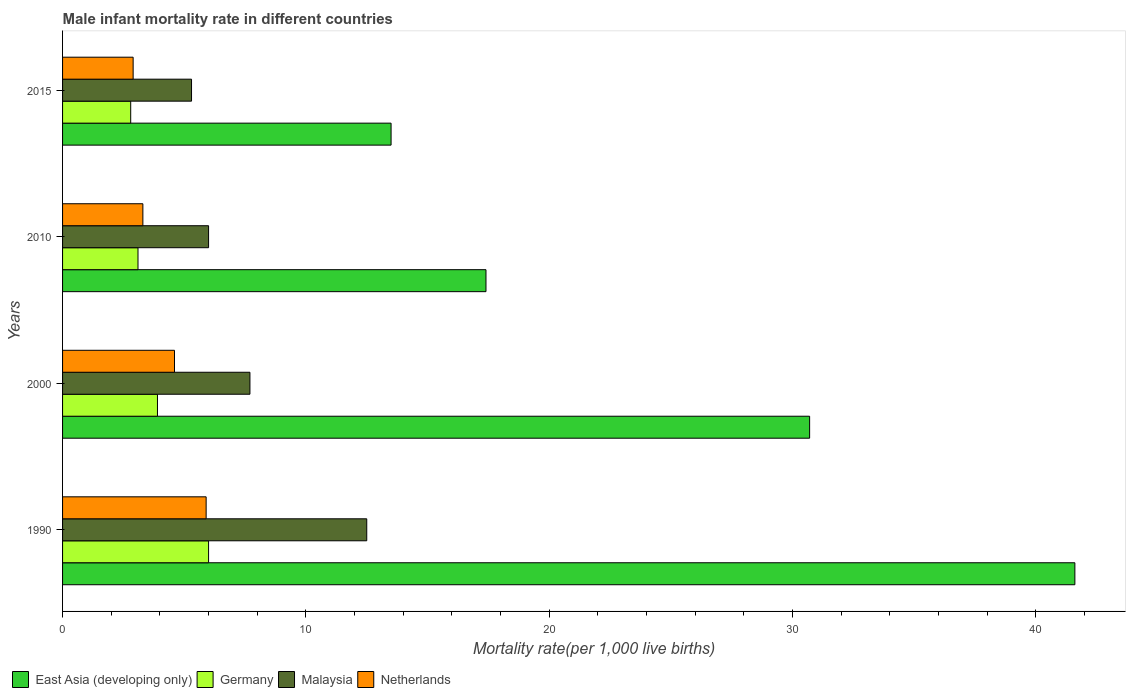How many groups of bars are there?
Make the answer very short. 4. Are the number of bars on each tick of the Y-axis equal?
Make the answer very short. Yes. How many bars are there on the 1st tick from the top?
Your answer should be compact. 4. In how many cases, is the number of bars for a given year not equal to the number of legend labels?
Offer a terse response. 0. What is the male infant mortality rate in East Asia (developing only) in 2000?
Provide a short and direct response. 30.7. Across all years, what is the maximum male infant mortality rate in East Asia (developing only)?
Your answer should be very brief. 41.6. Across all years, what is the minimum male infant mortality rate in Netherlands?
Ensure brevity in your answer.  2.9. In which year was the male infant mortality rate in Malaysia minimum?
Your answer should be compact. 2015. What is the total male infant mortality rate in East Asia (developing only) in the graph?
Offer a terse response. 103.2. What is the difference between the male infant mortality rate in East Asia (developing only) in 2000 and the male infant mortality rate in Germany in 2015?
Your response must be concise. 27.9. What is the average male infant mortality rate in Netherlands per year?
Your response must be concise. 4.17. In the year 2000, what is the difference between the male infant mortality rate in Germany and male infant mortality rate in East Asia (developing only)?
Ensure brevity in your answer.  -26.8. What is the ratio of the male infant mortality rate in Germany in 2010 to that in 2015?
Provide a succinct answer. 1.11. Is the difference between the male infant mortality rate in Germany in 1990 and 2010 greater than the difference between the male infant mortality rate in East Asia (developing only) in 1990 and 2010?
Provide a succinct answer. No. What is the difference between the highest and the second highest male infant mortality rate in Malaysia?
Provide a short and direct response. 4.8. What is the difference between the highest and the lowest male infant mortality rate in East Asia (developing only)?
Ensure brevity in your answer.  28.1. In how many years, is the male infant mortality rate in Germany greater than the average male infant mortality rate in Germany taken over all years?
Make the answer very short. 1. Is it the case that in every year, the sum of the male infant mortality rate in Netherlands and male infant mortality rate in East Asia (developing only) is greater than the sum of male infant mortality rate in Germany and male infant mortality rate in Malaysia?
Provide a succinct answer. No. What does the 2nd bar from the bottom in 1990 represents?
Your response must be concise. Germany. Is it the case that in every year, the sum of the male infant mortality rate in Malaysia and male infant mortality rate in Germany is greater than the male infant mortality rate in East Asia (developing only)?
Make the answer very short. No. Are all the bars in the graph horizontal?
Provide a short and direct response. Yes. How many years are there in the graph?
Keep it short and to the point. 4. Does the graph contain any zero values?
Provide a short and direct response. No. How many legend labels are there?
Your answer should be compact. 4. What is the title of the graph?
Your answer should be very brief. Male infant mortality rate in different countries. Does "Italy" appear as one of the legend labels in the graph?
Provide a short and direct response. No. What is the label or title of the X-axis?
Give a very brief answer. Mortality rate(per 1,0 live births). What is the Mortality rate(per 1,000 live births) of East Asia (developing only) in 1990?
Your answer should be very brief. 41.6. What is the Mortality rate(per 1,000 live births) in Malaysia in 1990?
Give a very brief answer. 12.5. What is the Mortality rate(per 1,000 live births) in East Asia (developing only) in 2000?
Offer a very short reply. 30.7. What is the Mortality rate(per 1,000 live births) in Malaysia in 2000?
Provide a short and direct response. 7.7. What is the Mortality rate(per 1,000 live births) in Netherlands in 2000?
Your answer should be compact. 4.6. What is the Mortality rate(per 1,000 live births) in Germany in 2010?
Your answer should be very brief. 3.1. What is the Mortality rate(per 1,000 live births) of Netherlands in 2010?
Keep it short and to the point. 3.3. What is the Mortality rate(per 1,000 live births) in Germany in 2015?
Offer a terse response. 2.8. What is the Mortality rate(per 1,000 live births) in Netherlands in 2015?
Give a very brief answer. 2.9. Across all years, what is the maximum Mortality rate(per 1,000 live births) of East Asia (developing only)?
Your answer should be very brief. 41.6. Across all years, what is the maximum Mortality rate(per 1,000 live births) of Malaysia?
Make the answer very short. 12.5. Across all years, what is the minimum Mortality rate(per 1,000 live births) of Germany?
Your response must be concise. 2.8. Across all years, what is the minimum Mortality rate(per 1,000 live births) in Malaysia?
Provide a succinct answer. 5.3. What is the total Mortality rate(per 1,000 live births) of East Asia (developing only) in the graph?
Your response must be concise. 103.2. What is the total Mortality rate(per 1,000 live births) of Germany in the graph?
Provide a succinct answer. 15.8. What is the total Mortality rate(per 1,000 live births) in Malaysia in the graph?
Keep it short and to the point. 31.5. What is the difference between the Mortality rate(per 1,000 live births) in East Asia (developing only) in 1990 and that in 2000?
Your answer should be compact. 10.9. What is the difference between the Mortality rate(per 1,000 live births) in Malaysia in 1990 and that in 2000?
Offer a terse response. 4.8. What is the difference between the Mortality rate(per 1,000 live births) in Netherlands in 1990 and that in 2000?
Offer a very short reply. 1.3. What is the difference between the Mortality rate(per 1,000 live births) of East Asia (developing only) in 1990 and that in 2010?
Offer a very short reply. 24.2. What is the difference between the Mortality rate(per 1,000 live births) in Netherlands in 1990 and that in 2010?
Make the answer very short. 2.6. What is the difference between the Mortality rate(per 1,000 live births) in East Asia (developing only) in 1990 and that in 2015?
Keep it short and to the point. 28.1. What is the difference between the Mortality rate(per 1,000 live births) of Netherlands in 1990 and that in 2015?
Ensure brevity in your answer.  3. What is the difference between the Mortality rate(per 1,000 live births) of East Asia (developing only) in 2000 and that in 2015?
Provide a succinct answer. 17.2. What is the difference between the Mortality rate(per 1,000 live births) in Germany in 2000 and that in 2015?
Make the answer very short. 1.1. What is the difference between the Mortality rate(per 1,000 live births) in Netherlands in 2000 and that in 2015?
Your answer should be compact. 1.7. What is the difference between the Mortality rate(per 1,000 live births) of Netherlands in 2010 and that in 2015?
Ensure brevity in your answer.  0.4. What is the difference between the Mortality rate(per 1,000 live births) in East Asia (developing only) in 1990 and the Mortality rate(per 1,000 live births) in Germany in 2000?
Your response must be concise. 37.7. What is the difference between the Mortality rate(per 1,000 live births) of East Asia (developing only) in 1990 and the Mortality rate(per 1,000 live births) of Malaysia in 2000?
Keep it short and to the point. 33.9. What is the difference between the Mortality rate(per 1,000 live births) of East Asia (developing only) in 1990 and the Mortality rate(per 1,000 live births) of Netherlands in 2000?
Provide a short and direct response. 37. What is the difference between the Mortality rate(per 1,000 live births) of East Asia (developing only) in 1990 and the Mortality rate(per 1,000 live births) of Germany in 2010?
Keep it short and to the point. 38.5. What is the difference between the Mortality rate(per 1,000 live births) of East Asia (developing only) in 1990 and the Mortality rate(per 1,000 live births) of Malaysia in 2010?
Give a very brief answer. 35.6. What is the difference between the Mortality rate(per 1,000 live births) in East Asia (developing only) in 1990 and the Mortality rate(per 1,000 live births) in Netherlands in 2010?
Give a very brief answer. 38.3. What is the difference between the Mortality rate(per 1,000 live births) in Germany in 1990 and the Mortality rate(per 1,000 live births) in Malaysia in 2010?
Make the answer very short. 0. What is the difference between the Mortality rate(per 1,000 live births) in Malaysia in 1990 and the Mortality rate(per 1,000 live births) in Netherlands in 2010?
Your answer should be compact. 9.2. What is the difference between the Mortality rate(per 1,000 live births) in East Asia (developing only) in 1990 and the Mortality rate(per 1,000 live births) in Germany in 2015?
Provide a succinct answer. 38.8. What is the difference between the Mortality rate(per 1,000 live births) of East Asia (developing only) in 1990 and the Mortality rate(per 1,000 live births) of Malaysia in 2015?
Ensure brevity in your answer.  36.3. What is the difference between the Mortality rate(per 1,000 live births) of East Asia (developing only) in 1990 and the Mortality rate(per 1,000 live births) of Netherlands in 2015?
Provide a short and direct response. 38.7. What is the difference between the Mortality rate(per 1,000 live births) in Germany in 1990 and the Mortality rate(per 1,000 live births) in Netherlands in 2015?
Your answer should be compact. 3.1. What is the difference between the Mortality rate(per 1,000 live births) of East Asia (developing only) in 2000 and the Mortality rate(per 1,000 live births) of Germany in 2010?
Keep it short and to the point. 27.6. What is the difference between the Mortality rate(per 1,000 live births) of East Asia (developing only) in 2000 and the Mortality rate(per 1,000 live births) of Malaysia in 2010?
Give a very brief answer. 24.7. What is the difference between the Mortality rate(per 1,000 live births) of East Asia (developing only) in 2000 and the Mortality rate(per 1,000 live births) of Netherlands in 2010?
Make the answer very short. 27.4. What is the difference between the Mortality rate(per 1,000 live births) of Germany in 2000 and the Mortality rate(per 1,000 live births) of Malaysia in 2010?
Offer a terse response. -2.1. What is the difference between the Mortality rate(per 1,000 live births) of Malaysia in 2000 and the Mortality rate(per 1,000 live births) of Netherlands in 2010?
Ensure brevity in your answer.  4.4. What is the difference between the Mortality rate(per 1,000 live births) in East Asia (developing only) in 2000 and the Mortality rate(per 1,000 live births) in Germany in 2015?
Your answer should be very brief. 27.9. What is the difference between the Mortality rate(per 1,000 live births) of East Asia (developing only) in 2000 and the Mortality rate(per 1,000 live births) of Malaysia in 2015?
Offer a very short reply. 25.4. What is the difference between the Mortality rate(per 1,000 live births) of East Asia (developing only) in 2000 and the Mortality rate(per 1,000 live births) of Netherlands in 2015?
Keep it short and to the point. 27.8. What is the difference between the Mortality rate(per 1,000 live births) of Germany in 2000 and the Mortality rate(per 1,000 live births) of Malaysia in 2015?
Ensure brevity in your answer.  -1.4. What is the difference between the Mortality rate(per 1,000 live births) in Malaysia in 2000 and the Mortality rate(per 1,000 live births) in Netherlands in 2015?
Offer a very short reply. 4.8. What is the difference between the Mortality rate(per 1,000 live births) of East Asia (developing only) in 2010 and the Mortality rate(per 1,000 live births) of Germany in 2015?
Provide a short and direct response. 14.6. What is the difference between the Mortality rate(per 1,000 live births) in Germany in 2010 and the Mortality rate(per 1,000 live births) in Malaysia in 2015?
Ensure brevity in your answer.  -2.2. What is the difference between the Mortality rate(per 1,000 live births) in Malaysia in 2010 and the Mortality rate(per 1,000 live births) in Netherlands in 2015?
Your answer should be very brief. 3.1. What is the average Mortality rate(per 1,000 live births) of East Asia (developing only) per year?
Your answer should be compact. 25.8. What is the average Mortality rate(per 1,000 live births) in Germany per year?
Provide a short and direct response. 3.95. What is the average Mortality rate(per 1,000 live births) of Malaysia per year?
Your response must be concise. 7.88. What is the average Mortality rate(per 1,000 live births) in Netherlands per year?
Offer a very short reply. 4.17. In the year 1990, what is the difference between the Mortality rate(per 1,000 live births) in East Asia (developing only) and Mortality rate(per 1,000 live births) in Germany?
Offer a terse response. 35.6. In the year 1990, what is the difference between the Mortality rate(per 1,000 live births) in East Asia (developing only) and Mortality rate(per 1,000 live births) in Malaysia?
Provide a short and direct response. 29.1. In the year 1990, what is the difference between the Mortality rate(per 1,000 live births) in East Asia (developing only) and Mortality rate(per 1,000 live births) in Netherlands?
Your answer should be compact. 35.7. In the year 1990, what is the difference between the Mortality rate(per 1,000 live births) of Malaysia and Mortality rate(per 1,000 live births) of Netherlands?
Make the answer very short. 6.6. In the year 2000, what is the difference between the Mortality rate(per 1,000 live births) of East Asia (developing only) and Mortality rate(per 1,000 live births) of Germany?
Your answer should be very brief. 26.8. In the year 2000, what is the difference between the Mortality rate(per 1,000 live births) in East Asia (developing only) and Mortality rate(per 1,000 live births) in Netherlands?
Offer a very short reply. 26.1. In the year 2010, what is the difference between the Mortality rate(per 1,000 live births) in East Asia (developing only) and Mortality rate(per 1,000 live births) in Germany?
Ensure brevity in your answer.  14.3. In the year 2010, what is the difference between the Mortality rate(per 1,000 live births) of East Asia (developing only) and Mortality rate(per 1,000 live births) of Malaysia?
Your response must be concise. 11.4. In the year 2015, what is the difference between the Mortality rate(per 1,000 live births) of East Asia (developing only) and Mortality rate(per 1,000 live births) of Germany?
Give a very brief answer. 10.7. In the year 2015, what is the difference between the Mortality rate(per 1,000 live births) of East Asia (developing only) and Mortality rate(per 1,000 live births) of Malaysia?
Give a very brief answer. 8.2. In the year 2015, what is the difference between the Mortality rate(per 1,000 live births) of East Asia (developing only) and Mortality rate(per 1,000 live births) of Netherlands?
Your answer should be compact. 10.6. In the year 2015, what is the difference between the Mortality rate(per 1,000 live births) of Germany and Mortality rate(per 1,000 live births) of Malaysia?
Ensure brevity in your answer.  -2.5. In the year 2015, what is the difference between the Mortality rate(per 1,000 live births) in Germany and Mortality rate(per 1,000 live births) in Netherlands?
Your answer should be very brief. -0.1. What is the ratio of the Mortality rate(per 1,000 live births) of East Asia (developing only) in 1990 to that in 2000?
Offer a very short reply. 1.35. What is the ratio of the Mortality rate(per 1,000 live births) in Germany in 1990 to that in 2000?
Your response must be concise. 1.54. What is the ratio of the Mortality rate(per 1,000 live births) in Malaysia in 1990 to that in 2000?
Ensure brevity in your answer.  1.62. What is the ratio of the Mortality rate(per 1,000 live births) of Netherlands in 1990 to that in 2000?
Make the answer very short. 1.28. What is the ratio of the Mortality rate(per 1,000 live births) of East Asia (developing only) in 1990 to that in 2010?
Provide a succinct answer. 2.39. What is the ratio of the Mortality rate(per 1,000 live births) in Germany in 1990 to that in 2010?
Make the answer very short. 1.94. What is the ratio of the Mortality rate(per 1,000 live births) in Malaysia in 1990 to that in 2010?
Give a very brief answer. 2.08. What is the ratio of the Mortality rate(per 1,000 live births) of Netherlands in 1990 to that in 2010?
Offer a very short reply. 1.79. What is the ratio of the Mortality rate(per 1,000 live births) of East Asia (developing only) in 1990 to that in 2015?
Provide a succinct answer. 3.08. What is the ratio of the Mortality rate(per 1,000 live births) of Germany in 1990 to that in 2015?
Provide a short and direct response. 2.14. What is the ratio of the Mortality rate(per 1,000 live births) in Malaysia in 1990 to that in 2015?
Your response must be concise. 2.36. What is the ratio of the Mortality rate(per 1,000 live births) of Netherlands in 1990 to that in 2015?
Provide a short and direct response. 2.03. What is the ratio of the Mortality rate(per 1,000 live births) in East Asia (developing only) in 2000 to that in 2010?
Give a very brief answer. 1.76. What is the ratio of the Mortality rate(per 1,000 live births) in Germany in 2000 to that in 2010?
Your response must be concise. 1.26. What is the ratio of the Mortality rate(per 1,000 live births) of Malaysia in 2000 to that in 2010?
Offer a terse response. 1.28. What is the ratio of the Mortality rate(per 1,000 live births) of Netherlands in 2000 to that in 2010?
Offer a very short reply. 1.39. What is the ratio of the Mortality rate(per 1,000 live births) of East Asia (developing only) in 2000 to that in 2015?
Make the answer very short. 2.27. What is the ratio of the Mortality rate(per 1,000 live births) of Germany in 2000 to that in 2015?
Give a very brief answer. 1.39. What is the ratio of the Mortality rate(per 1,000 live births) in Malaysia in 2000 to that in 2015?
Offer a terse response. 1.45. What is the ratio of the Mortality rate(per 1,000 live births) in Netherlands in 2000 to that in 2015?
Provide a succinct answer. 1.59. What is the ratio of the Mortality rate(per 1,000 live births) of East Asia (developing only) in 2010 to that in 2015?
Your answer should be compact. 1.29. What is the ratio of the Mortality rate(per 1,000 live births) of Germany in 2010 to that in 2015?
Offer a terse response. 1.11. What is the ratio of the Mortality rate(per 1,000 live births) of Malaysia in 2010 to that in 2015?
Provide a short and direct response. 1.13. What is the ratio of the Mortality rate(per 1,000 live births) in Netherlands in 2010 to that in 2015?
Provide a short and direct response. 1.14. What is the difference between the highest and the lowest Mortality rate(per 1,000 live births) of East Asia (developing only)?
Provide a short and direct response. 28.1. 